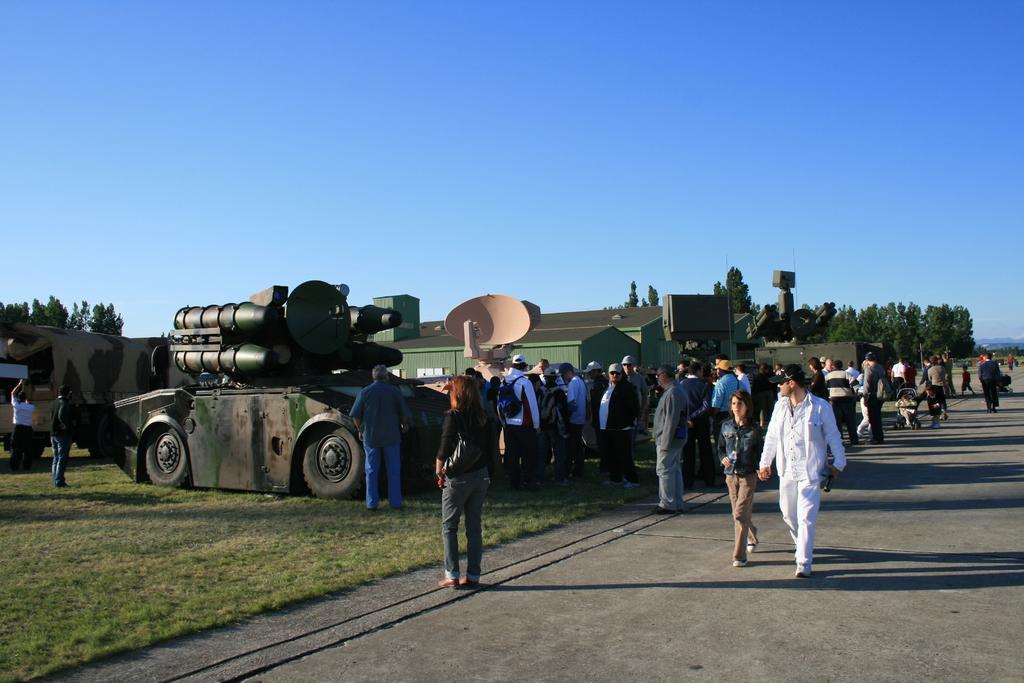In one or two sentences, can you explain what this image depicts? In this image we can see people. On the left there are vehicles and sheds. In the background there are trees and sky. At the bottom there is a road. 